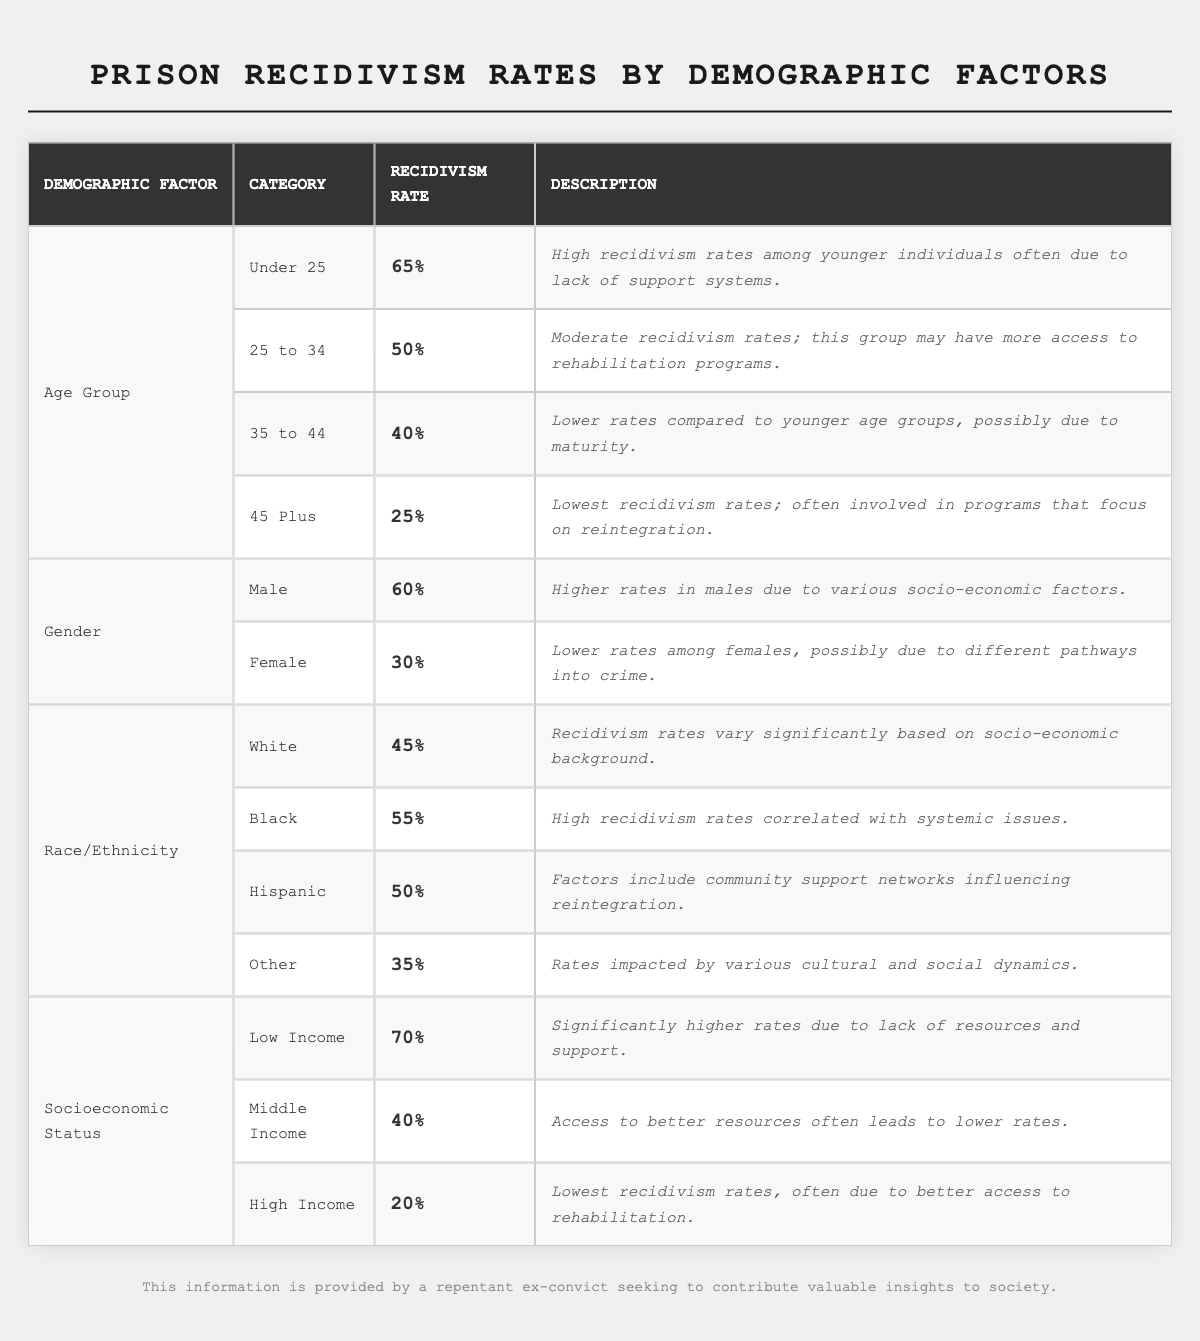What is the recidivism rate for individuals under 25? According to the table, the recidivism rate for individuals under 25 is listed directly as 65%.
Answer: 65% What is the recidivism rate for females? The table shows that the recidivism rate for females is 30%.
Answer: 30% Which age group has the lowest recidivism rate? The age group 45 Plus has the lowest recidivism rate at 25%.
Answer: 25% What is the difference in recidivism rates between low-income and high-income individuals? The recidivism rate for low-income individuals is 70% and for high-income individuals is 20%. The difference is 70% - 20% = 50%.
Answer: 50% Is the recidivism rate higher for males than for females? Yes, the rate for males is 60%, which is higher than the 30% for females.
Answer: Yes What is the average recidivism rate for the age groups listed in the table? The recidivism rates for the age groups are 65%, 50%, 40%, and 25%. To find the average, you sum them (65 + 50 + 40 + 25 = 180) and divide by the number of groups (4). The average is 180 / 4 = 45%.
Answer: 45% Which demographic factor has the highest recidivism rate and what is that rate? The socioeconomic status of low income has the highest recidivism rate at 70%.
Answer: 70% Is the recidivism rate for Blacks higher than for Whites? Yes, the table shows that the recidivism rate for Blacks is 55%, while for Whites it is 45%, indicating that Blacks have a higher rate.
Answer: Yes What is the recidivism rate for Hispanic individuals compared to that of Other races/ethnicities? The recidivism rate for Hispanic individuals is 50%, while for Other it is 35%. This means Hispanic individuals have a higher recidivism rate than Other races/ethnicities.
Answer: 50% for Hispanic, 35% for Other What is the total recidivism rate for all income categories combined, and how does it compare to the overall recidivism rate for all demographics? The income categories have recidivism rates of 70% (low), 40% (middle), and 20% (high). The total is 70% + 40% + 20% = 130%. To find the average, divide by 3: 130% / 3 = approximately 43.33%. Comparing this to the averages for age and gender demographics, it shows a lower recidivism tendency than low-income individuals alone.
Answer: 43.33% average for income categories What can be inferred about the recidivism rates for older demographics compared to younger ones? The data shows that recidivism rates decrease as age increases: Under 25 (65%), 25 to 34 (50%), 35 to 44 (40%), and 45 Plus (25%). This indicates that older demographics tend to have lower recidivism rates compared to younger ones.
Answer: Older demographics have lower recidivism rates What overall trend can be observed regarding gender and recidivism rates? The table shows males have a higher recidivism rate (60%) compared to females (30%), indicating a general trend of higher recidivism among males.
Answer: Males have higher recidivism rates 